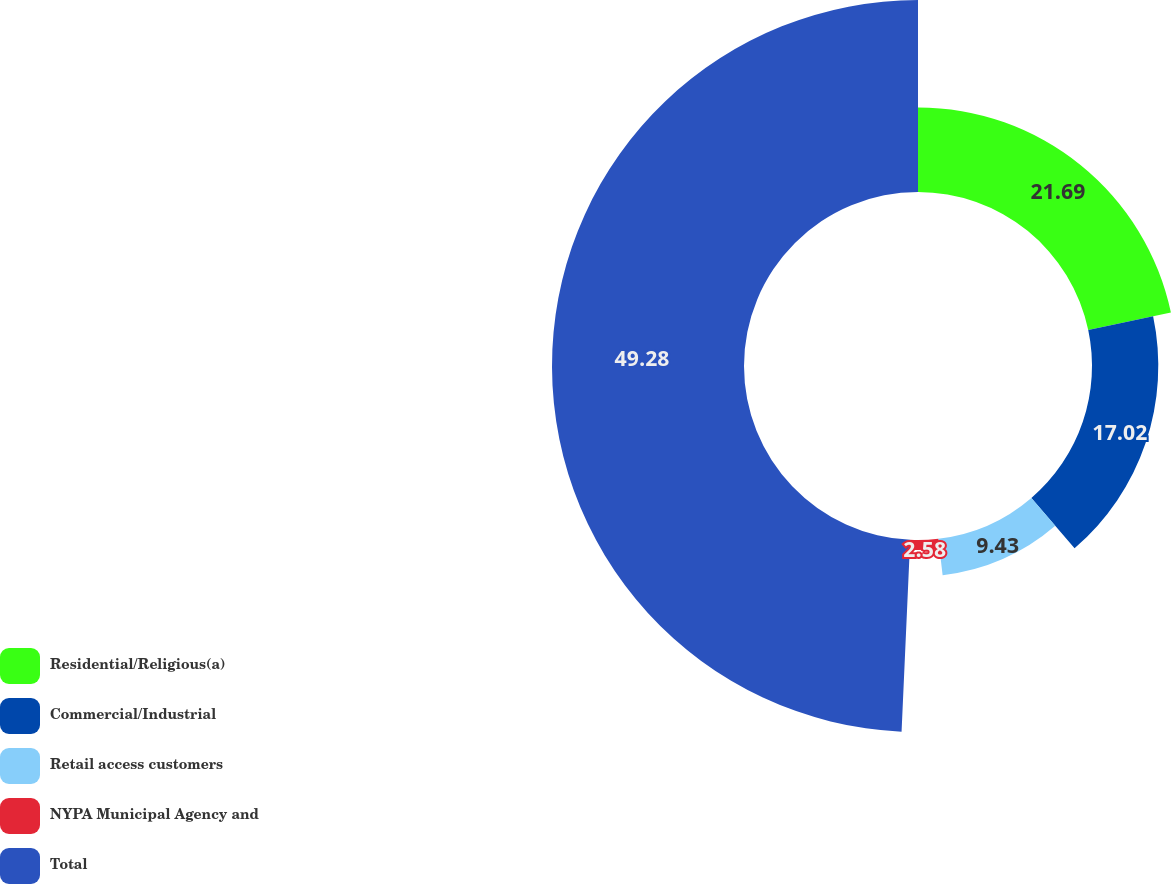<chart> <loc_0><loc_0><loc_500><loc_500><pie_chart><fcel>Residential/Religious(a)<fcel>Commercial/Industrial<fcel>Retail access customers<fcel>NYPA Municipal Agency and<fcel>Total<nl><fcel>21.69%<fcel>17.02%<fcel>9.43%<fcel>2.58%<fcel>49.29%<nl></chart> 